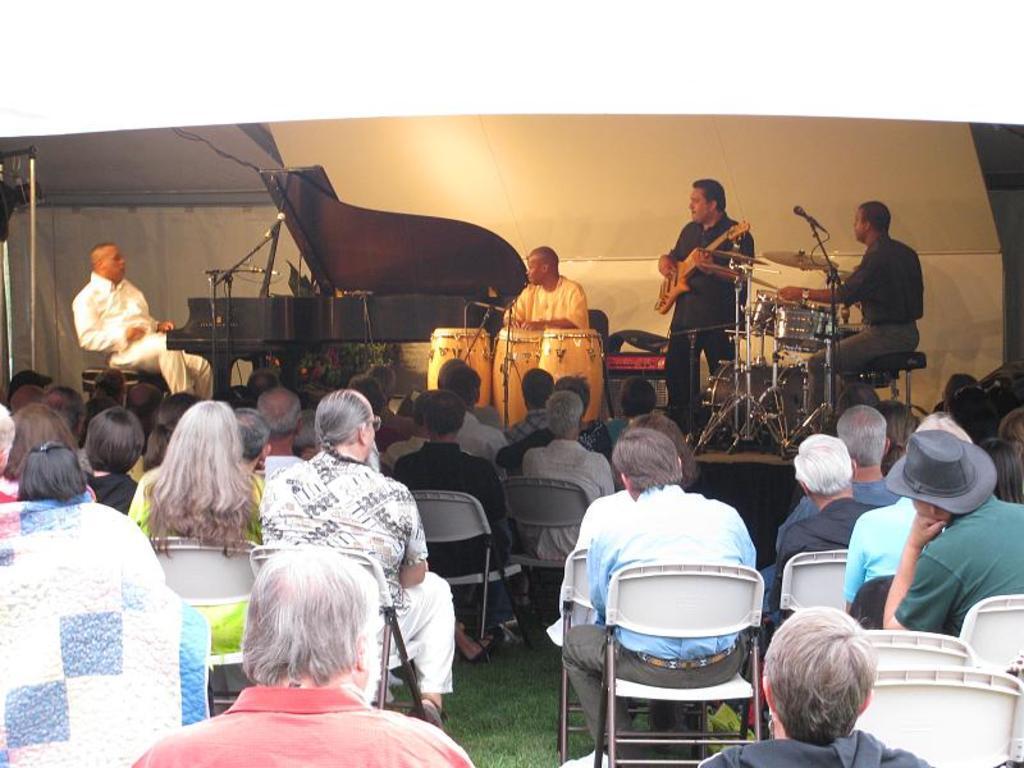Please provide a concise description of this image. In this image there are group of people sitting on the chair. There are three persons playing a musical instruments. 